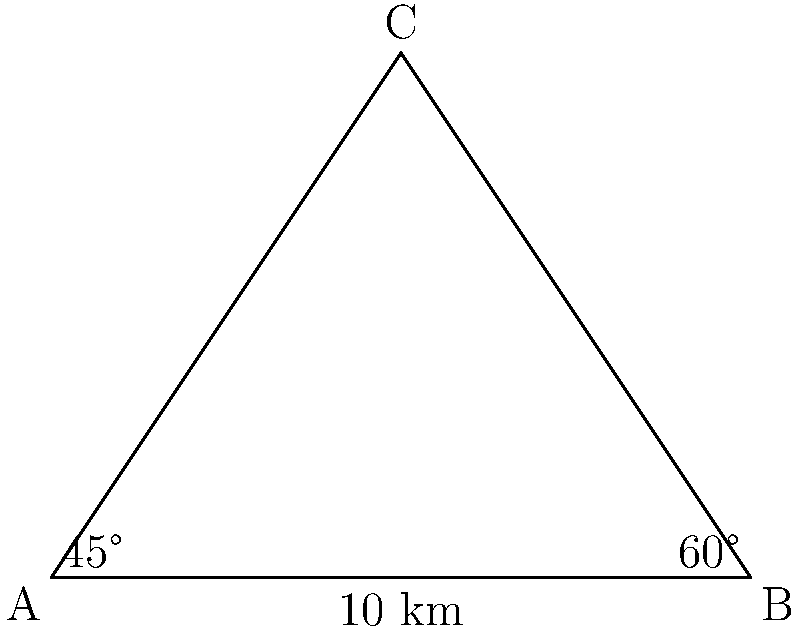As a campaign manager, you're planning rallies in three cities forming a triangle. The distance between cities A and B is 10 km, with the angle at A being 45° and the angle at B being 60°. Using the law of sines, calculate the distance between cities A and C (rounded to the nearest kilometer) to determine the travel time for your candidate. Let's solve this step-by-step using the law of sines:

1) The law of sines states: $$\frac{a}{\sin A} = \frac{b}{\sin B} = \frac{c}{\sin C}$$

   Where a, b, and c are the side lengths opposite to angles A, B, and C respectively.

2) We know:
   - Side c (between A and B) = 10 km
   - Angle A = 45°
   - Angle B = 60°

3) We need to find side a (between B and C). Let's use:

   $$\frac{a}{\sin A} = \frac{c}{\sin C}$$

4) We don't know angle C, but we can find it:
   In a triangle, the sum of all angles is 180°
   C = 180° - 45° - 60° = 75°

5) Now we can set up our equation:

   $$\frac{a}{\sin 45°} = \frac{10}{\sin 75°}$$

6) Solve for a:

   $$a = \frac{10 \sin 45°}{\sin 75°}$$

7) Calculate:
   $$a = \frac{10 \cdot 0.7071}{0.9659} \approx 7.32$$

8) Rounding to the nearest kilometer:
   a ≈ 7 km

Therefore, the distance between cities A and C is approximately 7 km.
Answer: 7 km 